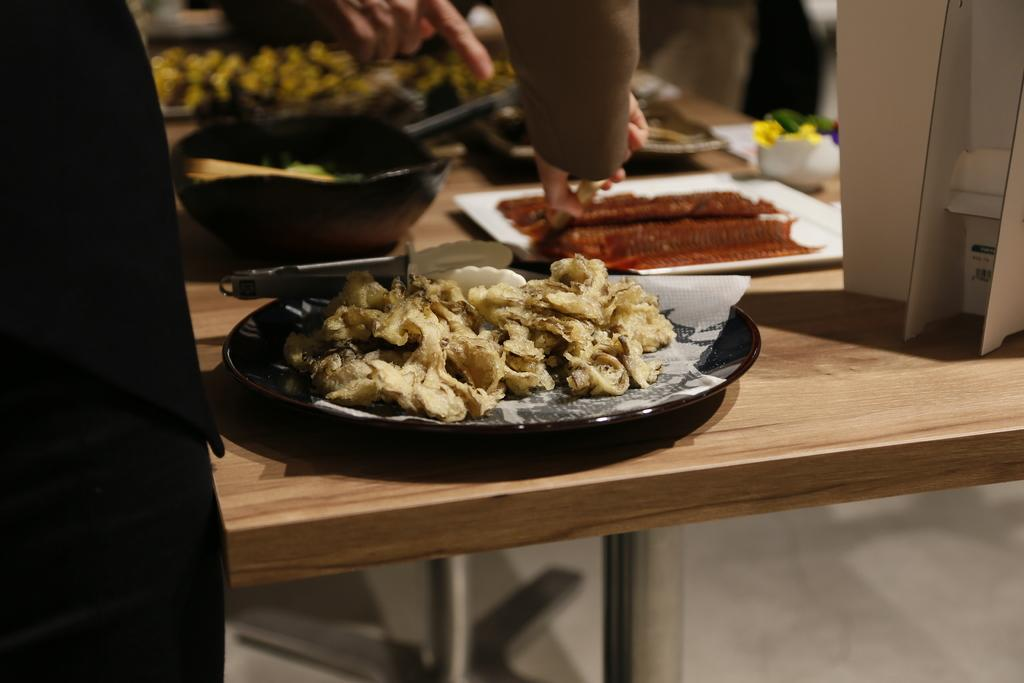What is present on the plates in the image? There is food in the plates in the image. What other type of dish is present in the image? There is a bowl in the image. Can you describe the size of the bowl in the image? There is a small ceramic bowl in the image. Where are the plates, bowl, and other objects located in the image? The objects are on a table in the image. Whose hands are visible in the image? Human hands are visible in the image. What type of winter clothing is being worn by the visitor in the image? There is no visitor or winter clothing present in the image. What is the hook used for in the image? There is no hook present in the image. 